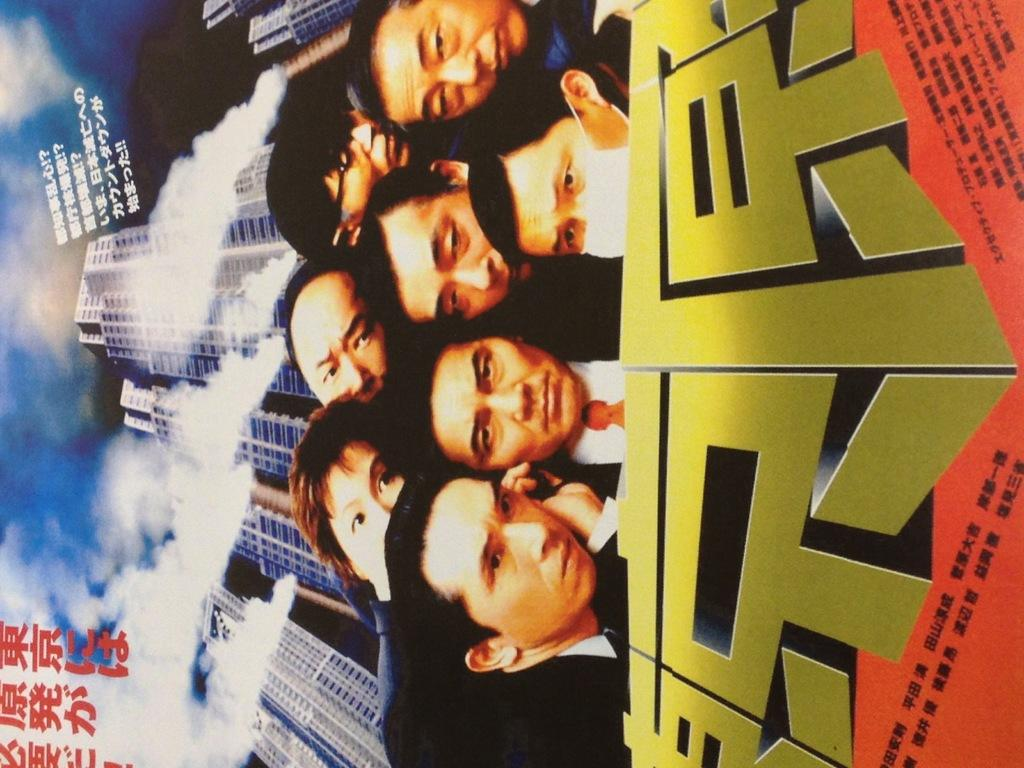What is the main subject of the poster in the image? There is a poster in the image, and it features people and buildings. Can you describe the background of the poster? The sky is visible in the background of the poster. Are there any words or letters on the poster? Yes, there is some text on the poster. How many planes can be seen flying in the sky on the poster? There are no planes visible in the sky on the poster; it only features people, buildings, and text. What is the cause of the arm depicted on the poster? There is no arm depicted on the poster; it only features people, buildings, and text. 